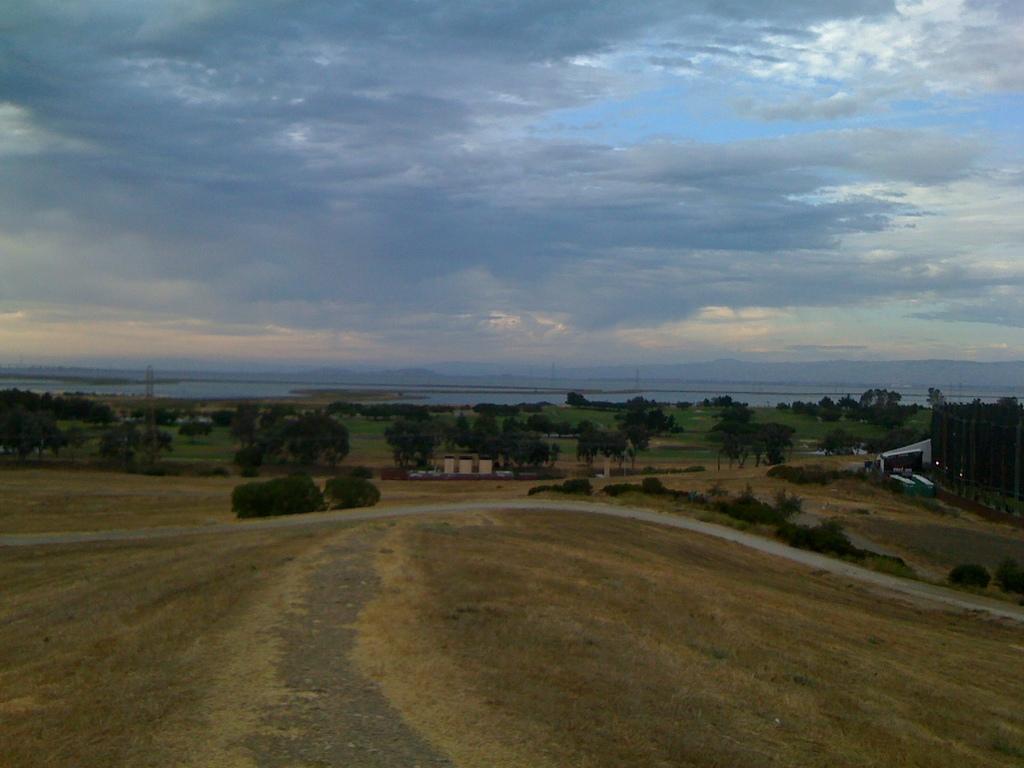How would you summarize this image in a sentence or two? This picture is clicked outside. In the center we can see the plants, trees, vehicles and some other objects. In the background we can see the sky which is full of clouds and we can see the water body and many other objects. 